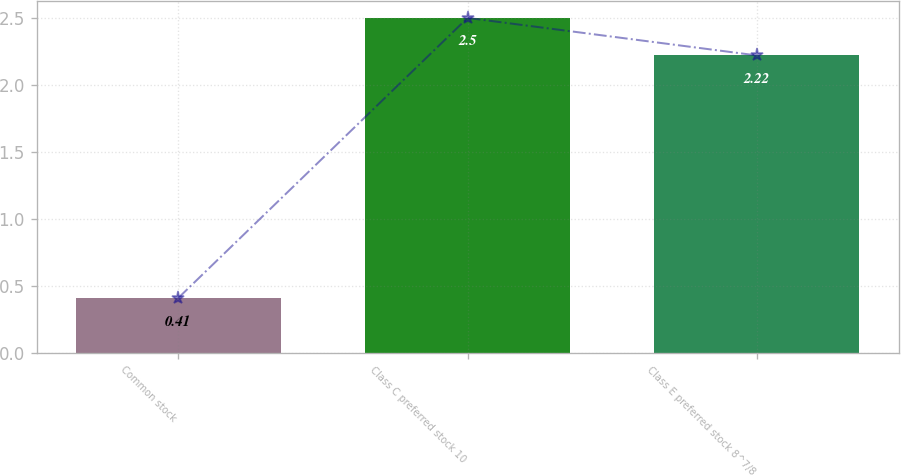<chart> <loc_0><loc_0><loc_500><loc_500><bar_chart><fcel>Common stock<fcel>Class C preferred stock 10<fcel>Class E preferred stock 8^7/8<nl><fcel>0.41<fcel>2.5<fcel>2.22<nl></chart> 